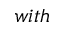Convert formula to latex. <formula><loc_0><loc_0><loc_500><loc_500>w i t h</formula> 